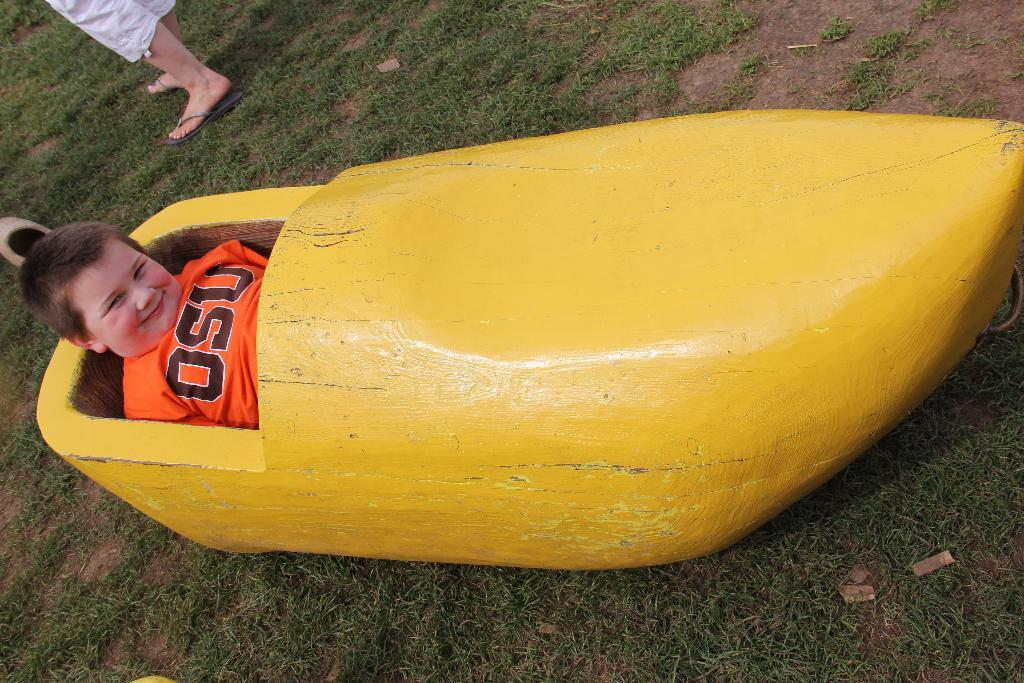<image>
Relay a brief, clear account of the picture shown. A boy is sitting inside a yellow wooden wagon shaped like a banana and his shirt says OSU.. 